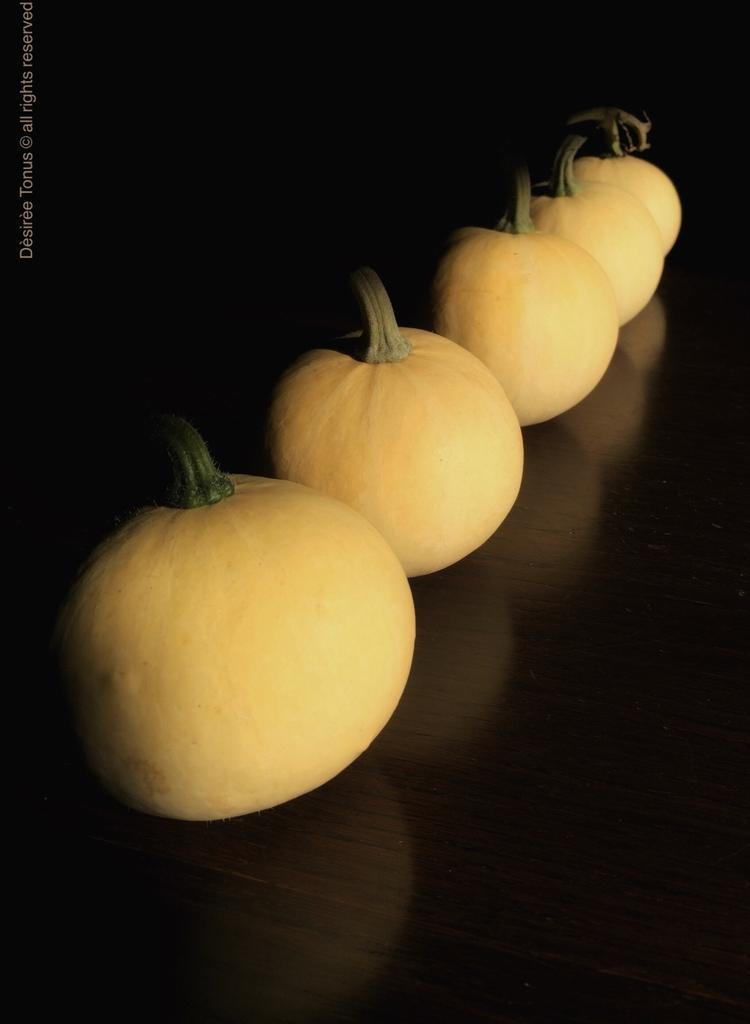What type of vegetable is present in the image? There are pumpkins in the image. What body of water can be seen in the image? There is no body of water present in the image; it only features pumpkins. How does the pumpkin stop the car in the image? Pumpkins do not have the ability to stop cars, and there is no car present in the image. 